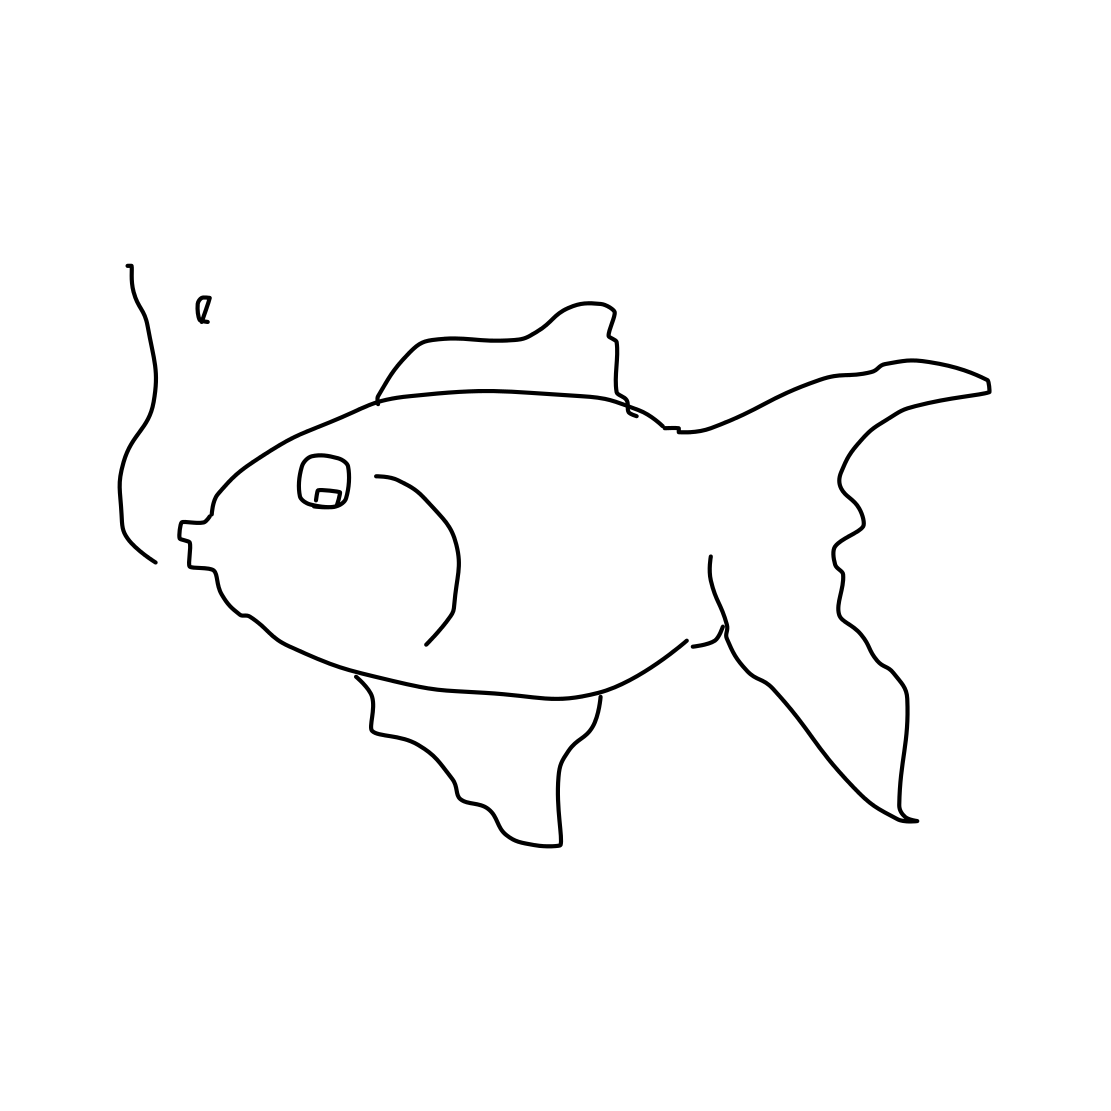Can you tell me more about the style of this drawing? The drawing is characterized by a minimalist and almost abstract style. It uses loose, free-form lines to suggest the shape and features of a fish without providing detailed realism. This kind of sketch might be used to convey a concept quickly or to capture the spontaneous essence of the subject. What does this style of drawing tell us about the artist's intentions? This artistic approach often indicates a focus on the immediacy of expression over technical precision. The artist may value the act of creation itself, or perhaps the fluidity and dynamic nature of their subject, over a polished finished product. It suggests a playful, exploratory mindset where the process is just as important as the final result. 